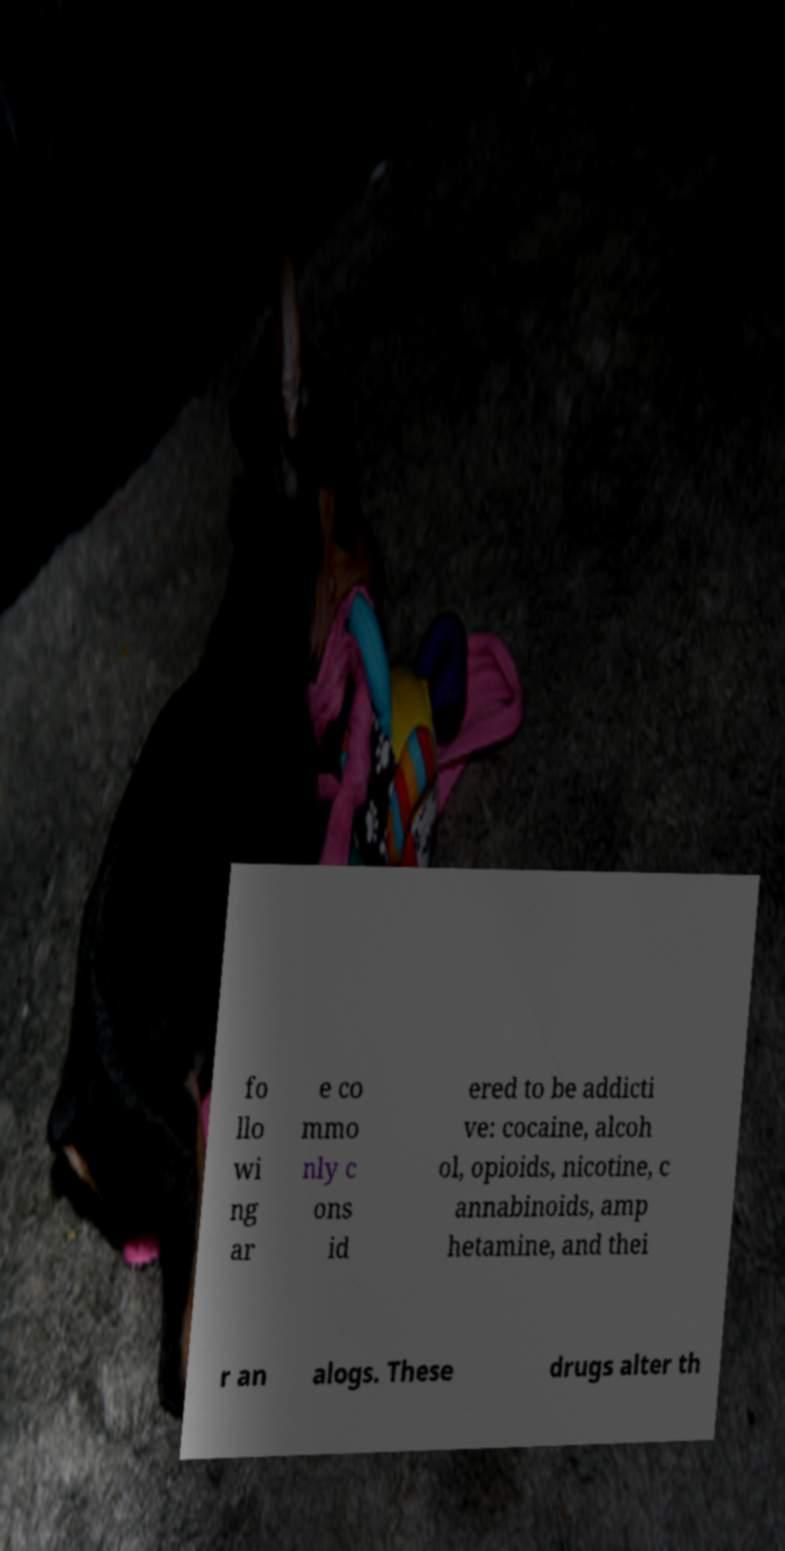For documentation purposes, I need the text within this image transcribed. Could you provide that? fo llo wi ng ar e co mmo nly c ons id ered to be addicti ve: cocaine, alcoh ol, opioids, nicotine, c annabinoids, amp hetamine, and thei r an alogs. These drugs alter th 